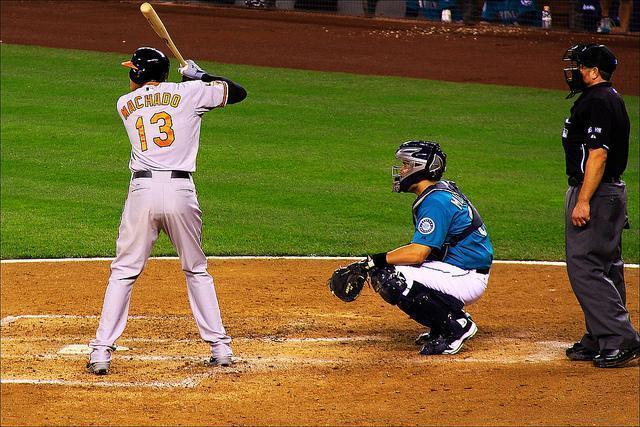How many people have on masks?
Give a very brief answer. 2. How many people are there?
Give a very brief answer. 3. 